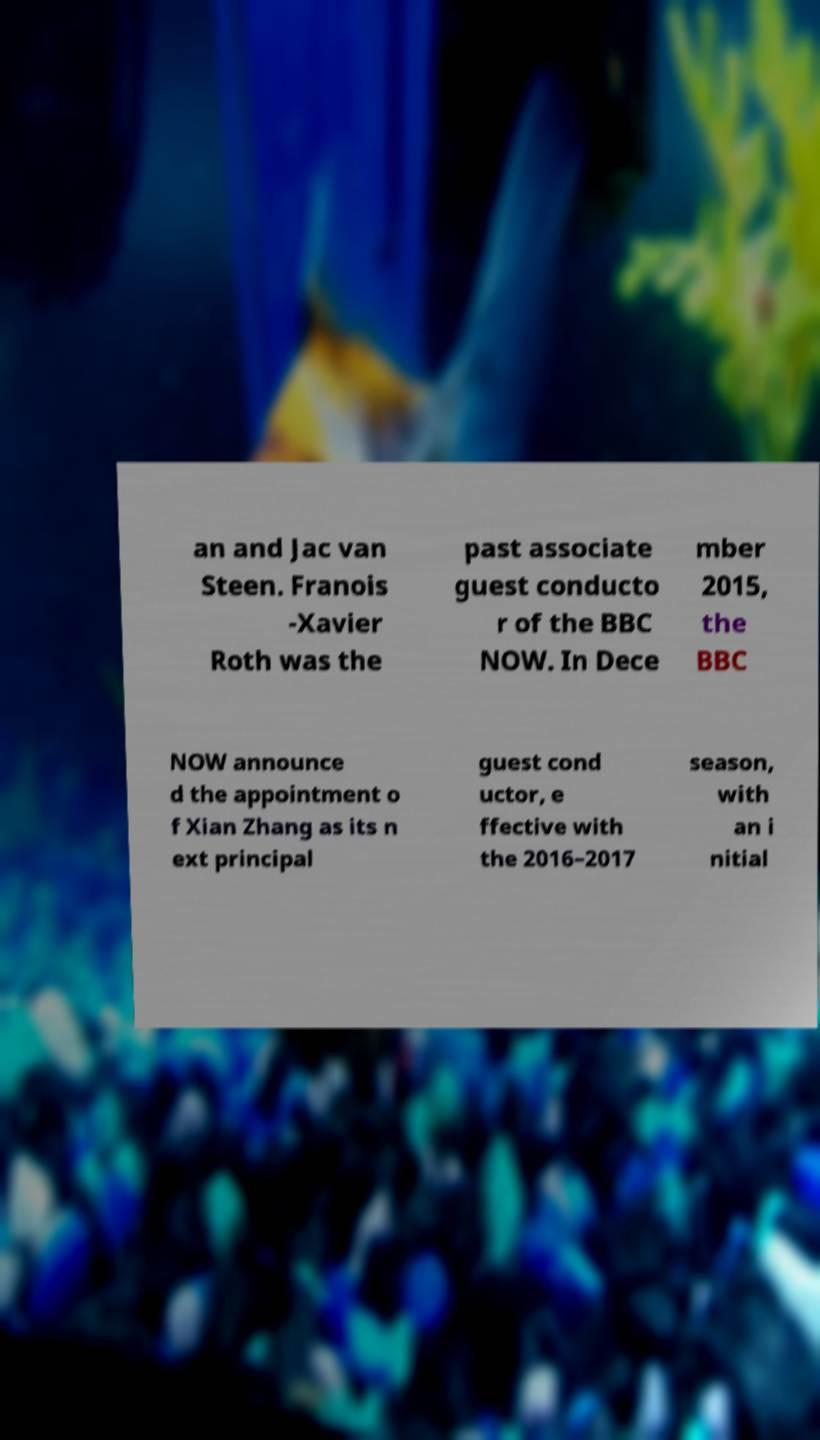Could you assist in decoding the text presented in this image and type it out clearly? an and Jac van Steen. Franois -Xavier Roth was the past associate guest conducto r of the BBC NOW. In Dece mber 2015, the BBC NOW announce d the appointment o f Xian Zhang as its n ext principal guest cond uctor, e ffective with the 2016–2017 season, with an i nitial 